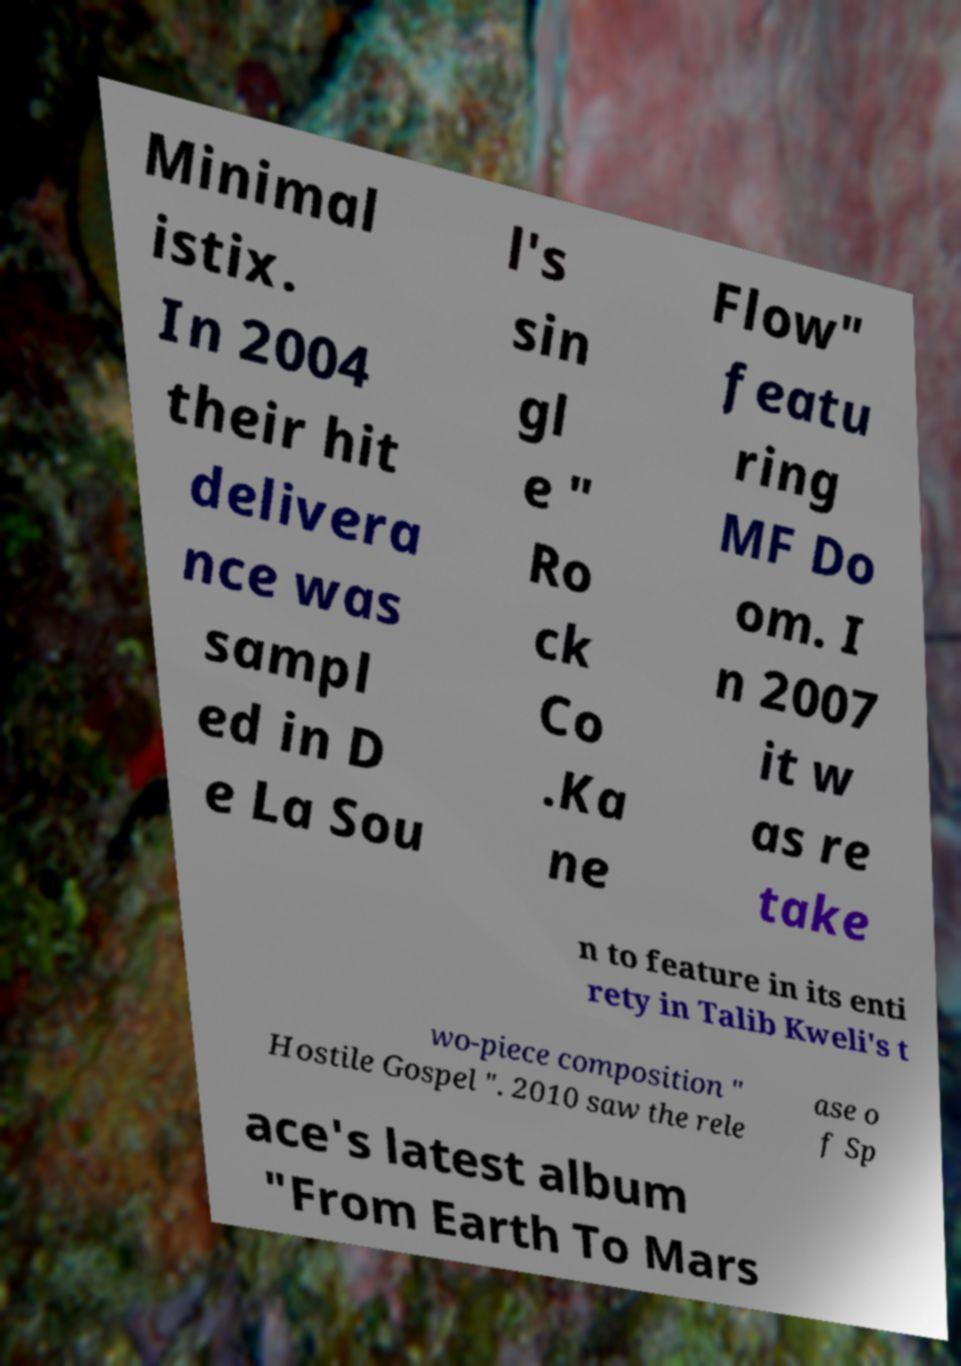Please read and relay the text visible in this image. What does it say? Minimal istix. In 2004 their hit delivera nce was sampl ed in D e La Sou l's sin gl e " Ro ck Co .Ka ne Flow" featu ring MF Do om. I n 2007 it w as re take n to feature in its enti rety in Talib Kweli's t wo-piece composition " Hostile Gospel ". 2010 saw the rele ase o f Sp ace's latest album "From Earth To Mars 